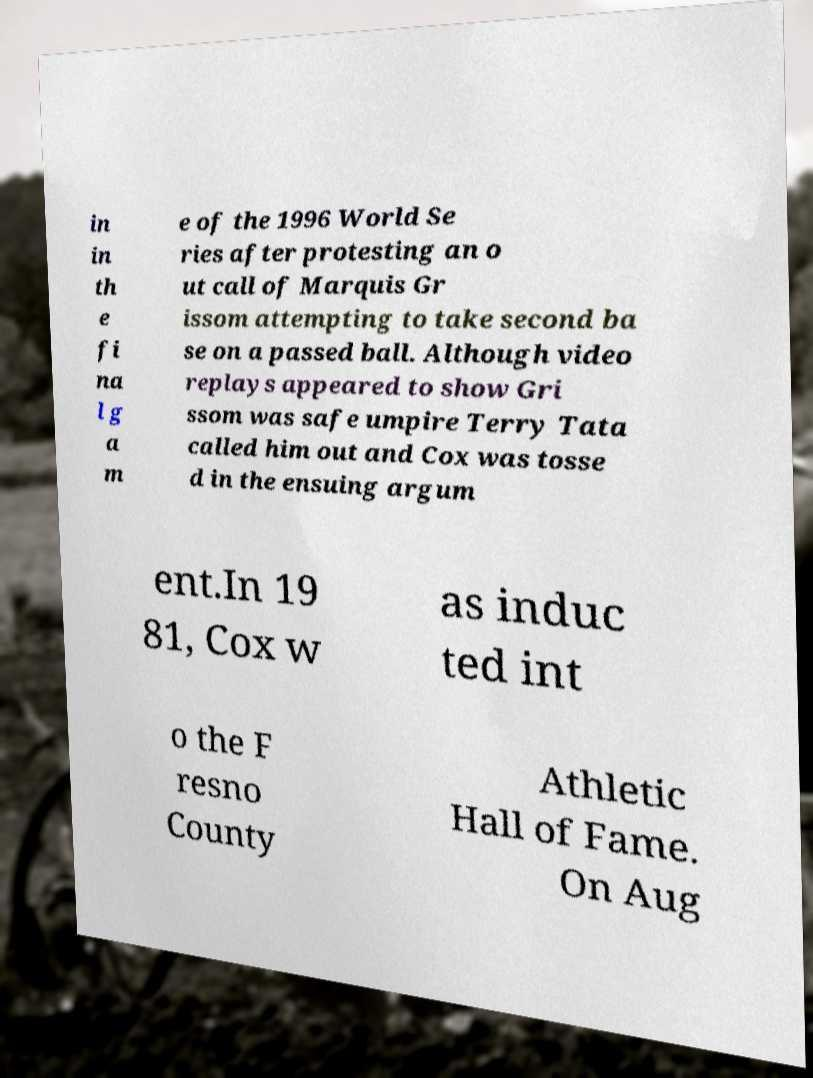There's text embedded in this image that I need extracted. Can you transcribe it verbatim? in in th e fi na l g a m e of the 1996 World Se ries after protesting an o ut call of Marquis Gr issom attempting to take second ba se on a passed ball. Although video replays appeared to show Gri ssom was safe umpire Terry Tata called him out and Cox was tosse d in the ensuing argum ent.In 19 81, Cox w as induc ted int o the F resno County Athletic Hall of Fame. On Aug 